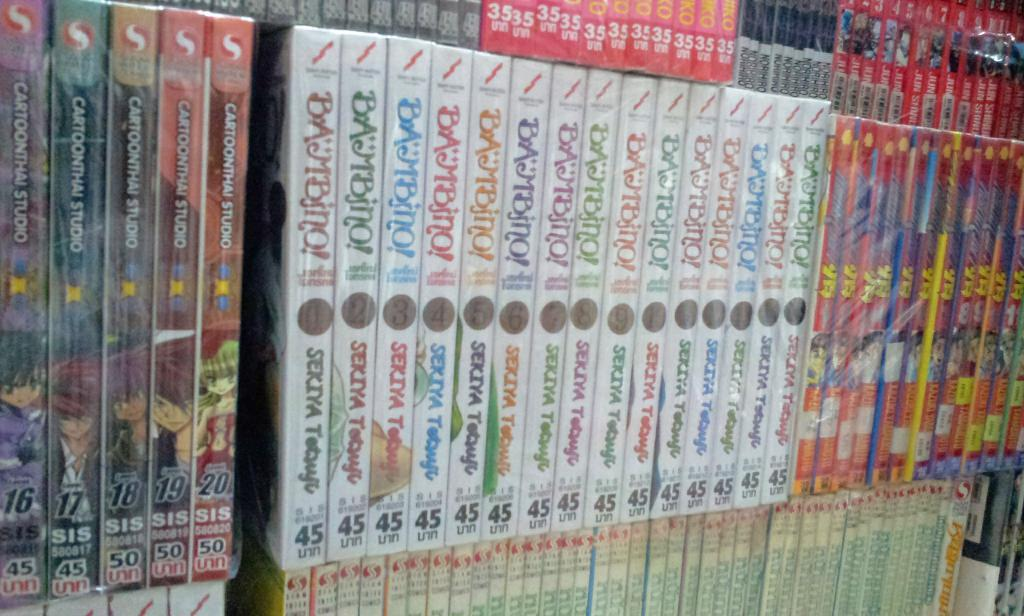Provide a one-sentence caption for the provided image. A lot of DVD"s with the number 45 are on a shelf stacked next to each other. 